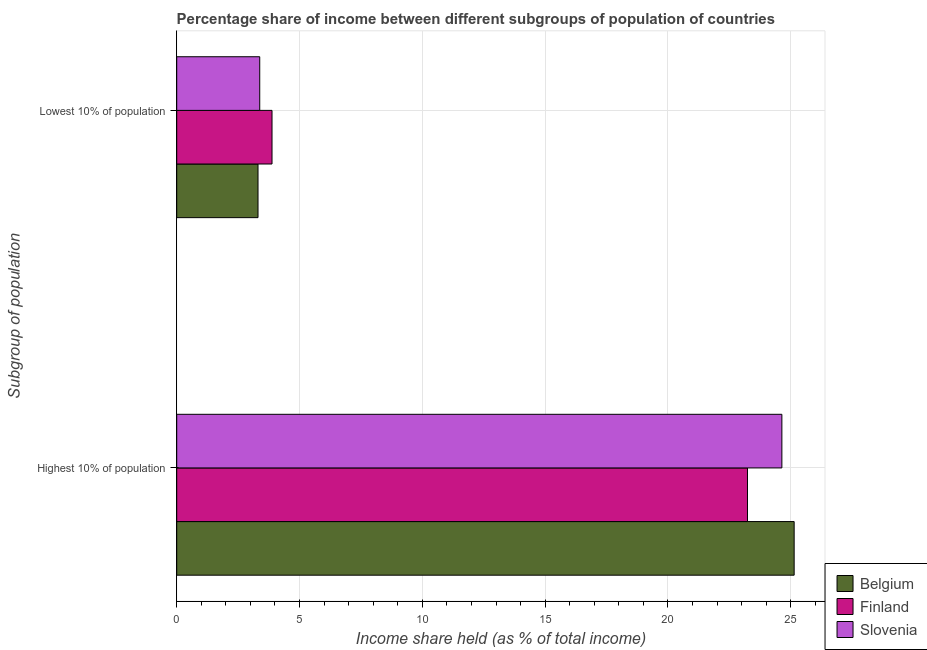How many different coloured bars are there?
Give a very brief answer. 3. How many groups of bars are there?
Provide a succinct answer. 2. Are the number of bars per tick equal to the number of legend labels?
Keep it short and to the point. Yes. Are the number of bars on each tick of the Y-axis equal?
Ensure brevity in your answer.  Yes. How many bars are there on the 1st tick from the top?
Offer a terse response. 3. How many bars are there on the 1st tick from the bottom?
Offer a very short reply. 3. What is the label of the 2nd group of bars from the top?
Offer a terse response. Highest 10% of population. What is the income share held by lowest 10% of the population in Slovenia?
Make the answer very short. 3.38. Across all countries, what is the maximum income share held by highest 10% of the population?
Offer a terse response. 25.14. Across all countries, what is the minimum income share held by highest 10% of the population?
Offer a very short reply. 23.24. In which country was the income share held by lowest 10% of the population maximum?
Offer a very short reply. Finland. What is the total income share held by lowest 10% of the population in the graph?
Offer a terse response. 10.57. What is the difference between the income share held by lowest 10% of the population in Belgium and that in Slovenia?
Give a very brief answer. -0.07. What is the difference between the income share held by highest 10% of the population in Finland and the income share held by lowest 10% of the population in Belgium?
Make the answer very short. 19.93. What is the average income share held by lowest 10% of the population per country?
Offer a very short reply. 3.52. What is the difference between the income share held by highest 10% of the population and income share held by lowest 10% of the population in Belgium?
Your answer should be very brief. 21.83. In how many countries, is the income share held by highest 10% of the population greater than 12 %?
Provide a short and direct response. 3. What is the ratio of the income share held by highest 10% of the population in Belgium to that in Slovenia?
Provide a succinct answer. 1.02. What does the 3rd bar from the bottom in Highest 10% of population represents?
Your answer should be very brief. Slovenia. How many bars are there?
Your response must be concise. 6. Are all the bars in the graph horizontal?
Keep it short and to the point. Yes. How many countries are there in the graph?
Provide a short and direct response. 3. What is the difference between two consecutive major ticks on the X-axis?
Provide a succinct answer. 5. Are the values on the major ticks of X-axis written in scientific E-notation?
Offer a terse response. No. Where does the legend appear in the graph?
Offer a very short reply. Bottom right. How many legend labels are there?
Make the answer very short. 3. How are the legend labels stacked?
Your answer should be very brief. Vertical. What is the title of the graph?
Offer a terse response. Percentage share of income between different subgroups of population of countries. Does "Malta" appear as one of the legend labels in the graph?
Ensure brevity in your answer.  No. What is the label or title of the X-axis?
Make the answer very short. Income share held (as % of total income). What is the label or title of the Y-axis?
Your answer should be compact. Subgroup of population. What is the Income share held (as % of total income) of Belgium in Highest 10% of population?
Offer a terse response. 25.14. What is the Income share held (as % of total income) of Finland in Highest 10% of population?
Give a very brief answer. 23.24. What is the Income share held (as % of total income) in Slovenia in Highest 10% of population?
Provide a succinct answer. 24.64. What is the Income share held (as % of total income) of Belgium in Lowest 10% of population?
Offer a very short reply. 3.31. What is the Income share held (as % of total income) of Finland in Lowest 10% of population?
Keep it short and to the point. 3.88. What is the Income share held (as % of total income) in Slovenia in Lowest 10% of population?
Provide a succinct answer. 3.38. Across all Subgroup of population, what is the maximum Income share held (as % of total income) in Belgium?
Your answer should be very brief. 25.14. Across all Subgroup of population, what is the maximum Income share held (as % of total income) of Finland?
Your answer should be very brief. 23.24. Across all Subgroup of population, what is the maximum Income share held (as % of total income) of Slovenia?
Your answer should be compact. 24.64. Across all Subgroup of population, what is the minimum Income share held (as % of total income) of Belgium?
Keep it short and to the point. 3.31. Across all Subgroup of population, what is the minimum Income share held (as % of total income) in Finland?
Offer a terse response. 3.88. Across all Subgroup of population, what is the minimum Income share held (as % of total income) of Slovenia?
Keep it short and to the point. 3.38. What is the total Income share held (as % of total income) of Belgium in the graph?
Provide a short and direct response. 28.45. What is the total Income share held (as % of total income) of Finland in the graph?
Your response must be concise. 27.12. What is the total Income share held (as % of total income) in Slovenia in the graph?
Offer a terse response. 28.02. What is the difference between the Income share held (as % of total income) of Belgium in Highest 10% of population and that in Lowest 10% of population?
Offer a very short reply. 21.83. What is the difference between the Income share held (as % of total income) in Finland in Highest 10% of population and that in Lowest 10% of population?
Offer a terse response. 19.36. What is the difference between the Income share held (as % of total income) of Slovenia in Highest 10% of population and that in Lowest 10% of population?
Make the answer very short. 21.26. What is the difference between the Income share held (as % of total income) of Belgium in Highest 10% of population and the Income share held (as % of total income) of Finland in Lowest 10% of population?
Your answer should be compact. 21.26. What is the difference between the Income share held (as % of total income) of Belgium in Highest 10% of population and the Income share held (as % of total income) of Slovenia in Lowest 10% of population?
Provide a short and direct response. 21.76. What is the difference between the Income share held (as % of total income) in Finland in Highest 10% of population and the Income share held (as % of total income) in Slovenia in Lowest 10% of population?
Provide a succinct answer. 19.86. What is the average Income share held (as % of total income) in Belgium per Subgroup of population?
Provide a short and direct response. 14.22. What is the average Income share held (as % of total income) of Finland per Subgroup of population?
Offer a very short reply. 13.56. What is the average Income share held (as % of total income) of Slovenia per Subgroup of population?
Provide a short and direct response. 14.01. What is the difference between the Income share held (as % of total income) of Belgium and Income share held (as % of total income) of Finland in Highest 10% of population?
Your response must be concise. 1.9. What is the difference between the Income share held (as % of total income) of Belgium and Income share held (as % of total income) of Finland in Lowest 10% of population?
Provide a short and direct response. -0.57. What is the difference between the Income share held (as % of total income) of Belgium and Income share held (as % of total income) of Slovenia in Lowest 10% of population?
Give a very brief answer. -0.07. What is the ratio of the Income share held (as % of total income) of Belgium in Highest 10% of population to that in Lowest 10% of population?
Make the answer very short. 7.6. What is the ratio of the Income share held (as % of total income) of Finland in Highest 10% of population to that in Lowest 10% of population?
Your answer should be very brief. 5.99. What is the ratio of the Income share held (as % of total income) in Slovenia in Highest 10% of population to that in Lowest 10% of population?
Offer a terse response. 7.29. What is the difference between the highest and the second highest Income share held (as % of total income) in Belgium?
Keep it short and to the point. 21.83. What is the difference between the highest and the second highest Income share held (as % of total income) of Finland?
Provide a short and direct response. 19.36. What is the difference between the highest and the second highest Income share held (as % of total income) of Slovenia?
Your response must be concise. 21.26. What is the difference between the highest and the lowest Income share held (as % of total income) of Belgium?
Offer a very short reply. 21.83. What is the difference between the highest and the lowest Income share held (as % of total income) of Finland?
Your response must be concise. 19.36. What is the difference between the highest and the lowest Income share held (as % of total income) of Slovenia?
Make the answer very short. 21.26. 